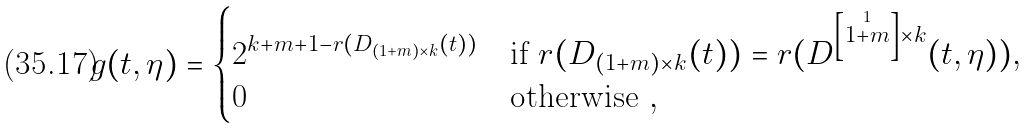<formula> <loc_0><loc_0><loc_500><loc_500>g ( t , \eta ) = \begin{cases} 2 ^ { k + m + 1 - r ( D _ { ( 1 + m ) \times k } ( t ) ) } & \text {if } r ( D _ { ( 1 + m ) \times k } ( t ) ) = r ( D ^ { \left [ \stackrel { 1 } { 1 + m } \right ] \times k } ( t , \eta ) ) , \\ 0 & \text {otherwise } , \end{cases}</formula> 